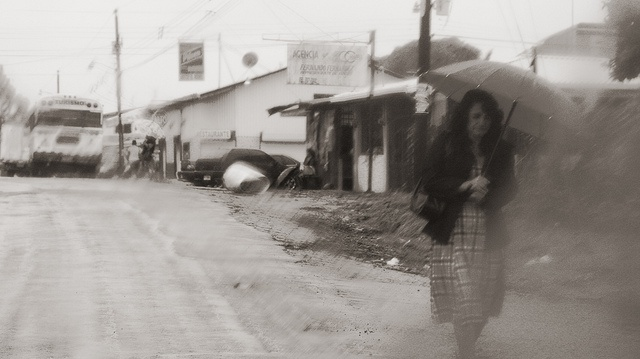Describe the objects in this image and their specific colors. I can see people in white, gray, and black tones, umbrella in white, gray, darkgray, and black tones, bus in white, gray, darkgray, lightgray, and black tones, car in white, black, and gray tones, and handbag in white, black, and gray tones in this image. 